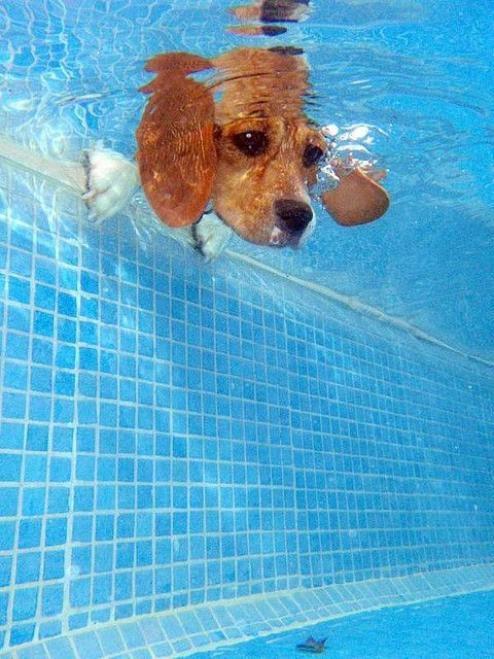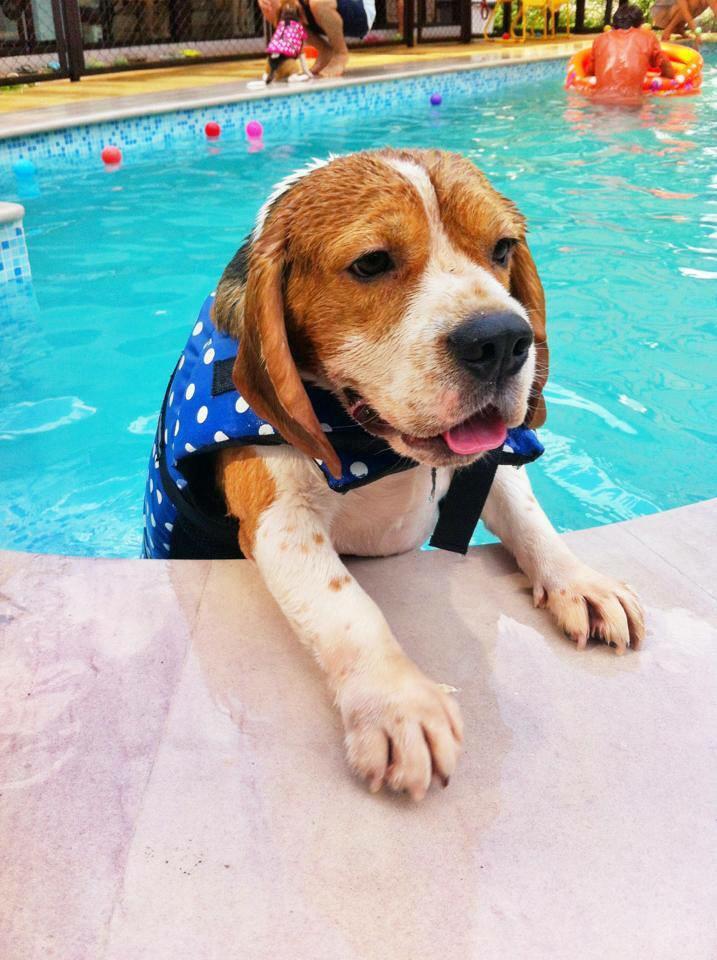The first image is the image on the left, the second image is the image on the right. For the images displayed, is the sentence "A person is visible in a pool that also has a dog in it." factually correct? Answer yes or no. Yes. The first image is the image on the left, the second image is the image on the right. Analyze the images presented: Is the assertion "There are two dogs in total." valid? Answer yes or no. Yes. 